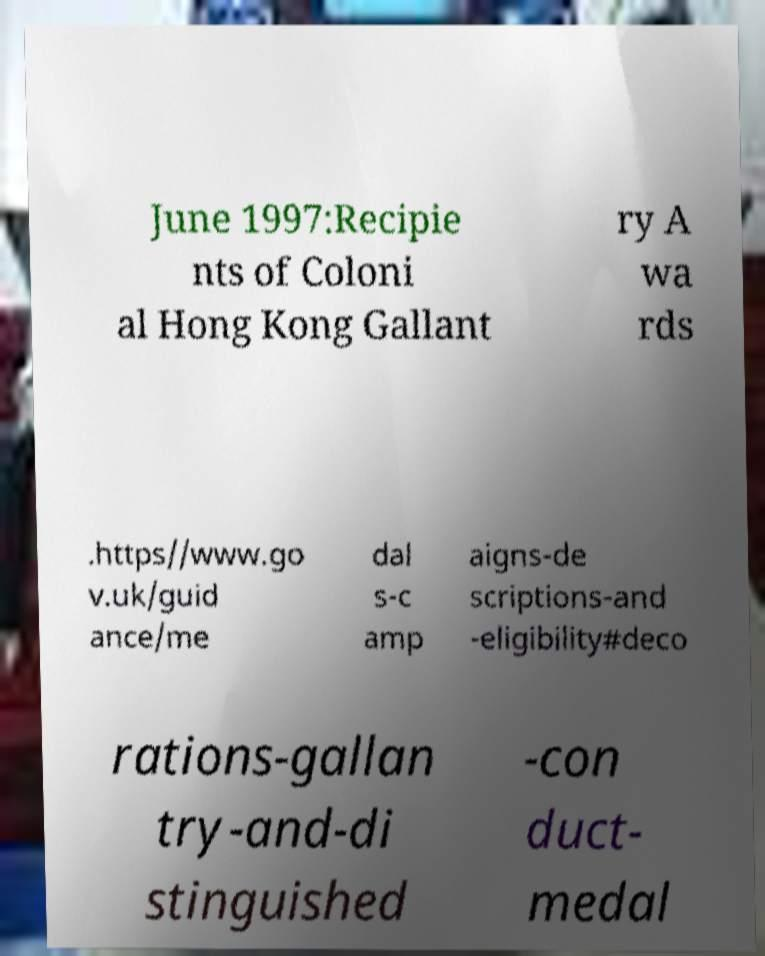Can you read and provide the text displayed in the image?This photo seems to have some interesting text. Can you extract and type it out for me? June 1997:Recipie nts of Coloni al Hong Kong Gallant ry A wa rds .https//www.go v.uk/guid ance/me dal s-c amp aigns-de scriptions-and -eligibility#deco rations-gallan try-and-di stinguished -con duct- medal 